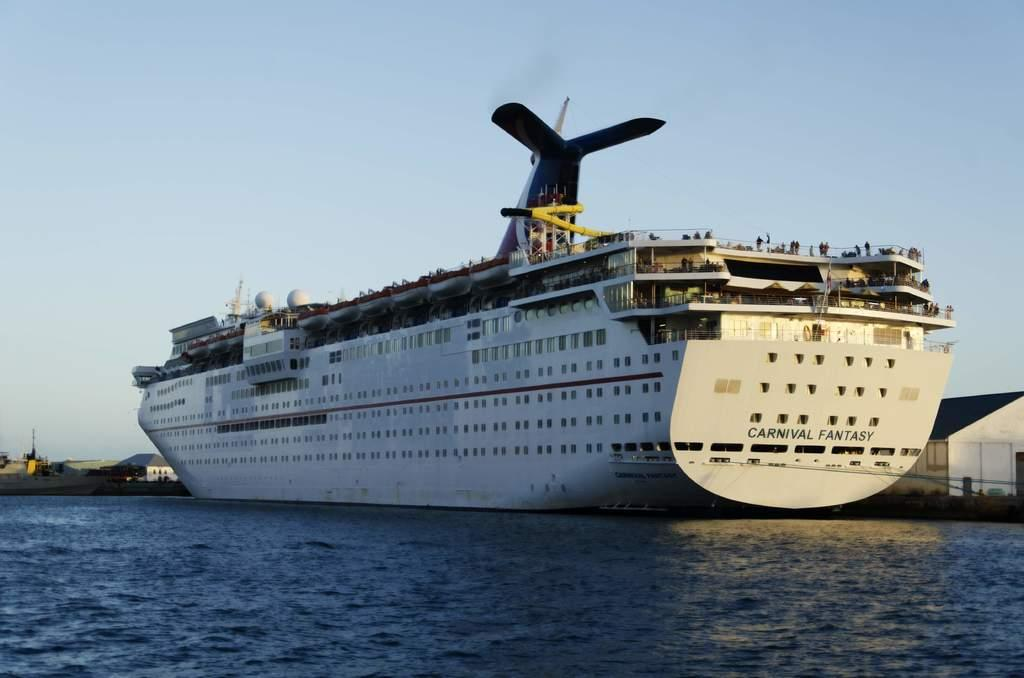Provide a one-sentence caption for the provided image. A cruise ship is sailing named Carnival Fantasy. 